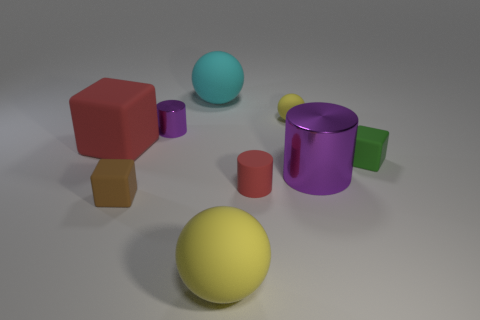Which object seems closest to the point of view? The object that appears to be closest is the large yellow sphere in the foreground. 